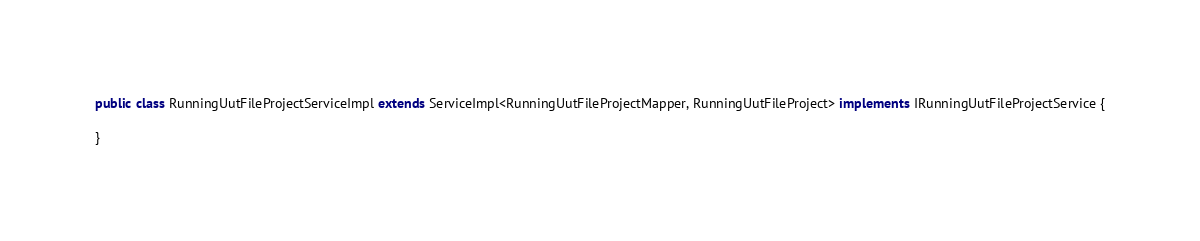<code> <loc_0><loc_0><loc_500><loc_500><_Java_>public class RunningUutFileProjectServiceImpl extends ServiceImpl<RunningUutFileProjectMapper, RunningUutFileProject> implements IRunningUutFileProjectService {

}
</code> 